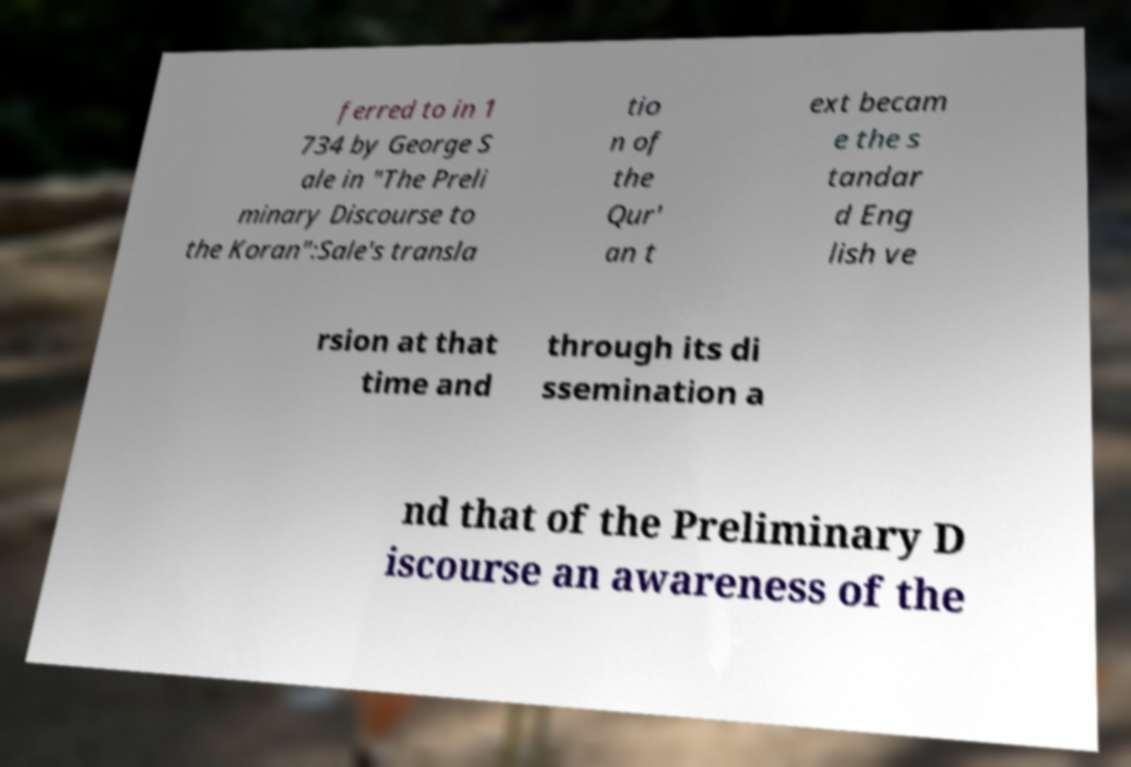Could you assist in decoding the text presented in this image and type it out clearly? ferred to in 1 734 by George S ale in "The Preli minary Discourse to the Koran":Sale's transla tio n of the Qur' an t ext becam e the s tandar d Eng lish ve rsion at that time and through its di ssemination a nd that of the Preliminary D iscourse an awareness of the 